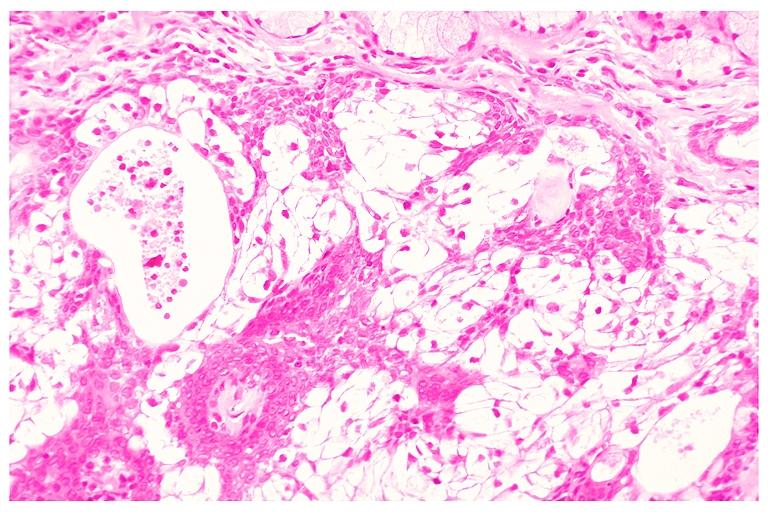s cleft palate present?
Answer the question using a single word or phrase. No 